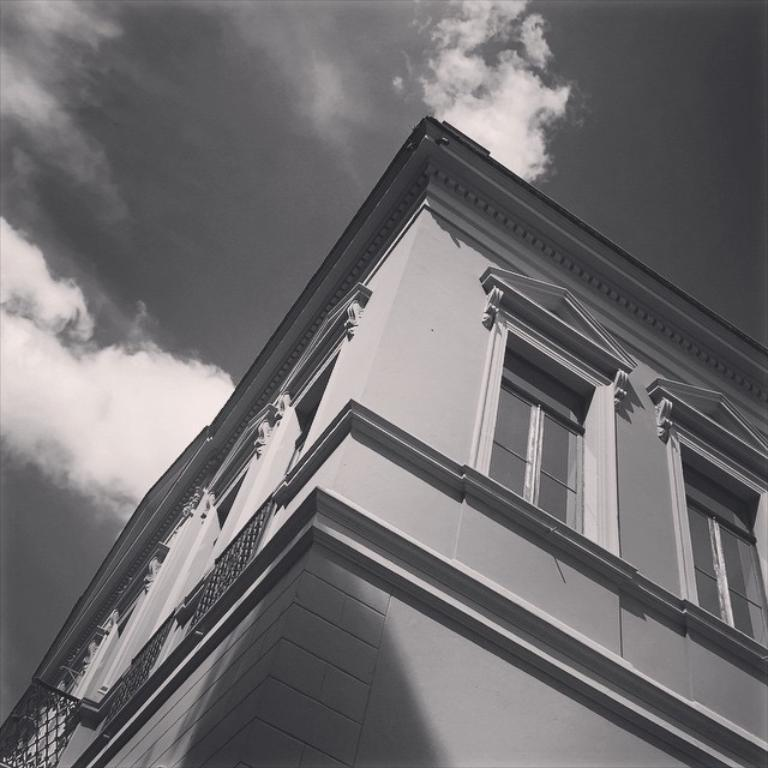What is the main subject of the image? There is a building in the image. What can be seen in the background of the image? There are clouds in the sky in the background of the image. What is the color scheme of the image? The image is black and white. What type of substance is the kitten playing with in the image? There is no kitten present in the image, so it is not possible to determine what substance it might be playing with. 